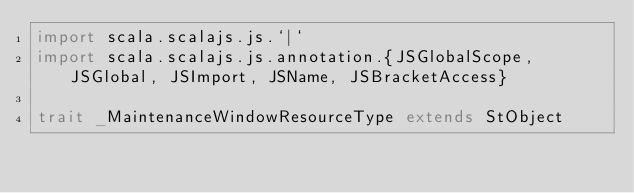<code> <loc_0><loc_0><loc_500><loc_500><_Scala_>import scala.scalajs.js.`|`
import scala.scalajs.js.annotation.{JSGlobalScope, JSGlobal, JSImport, JSName, JSBracketAccess}

trait _MaintenanceWindowResourceType extends StObject
</code> 